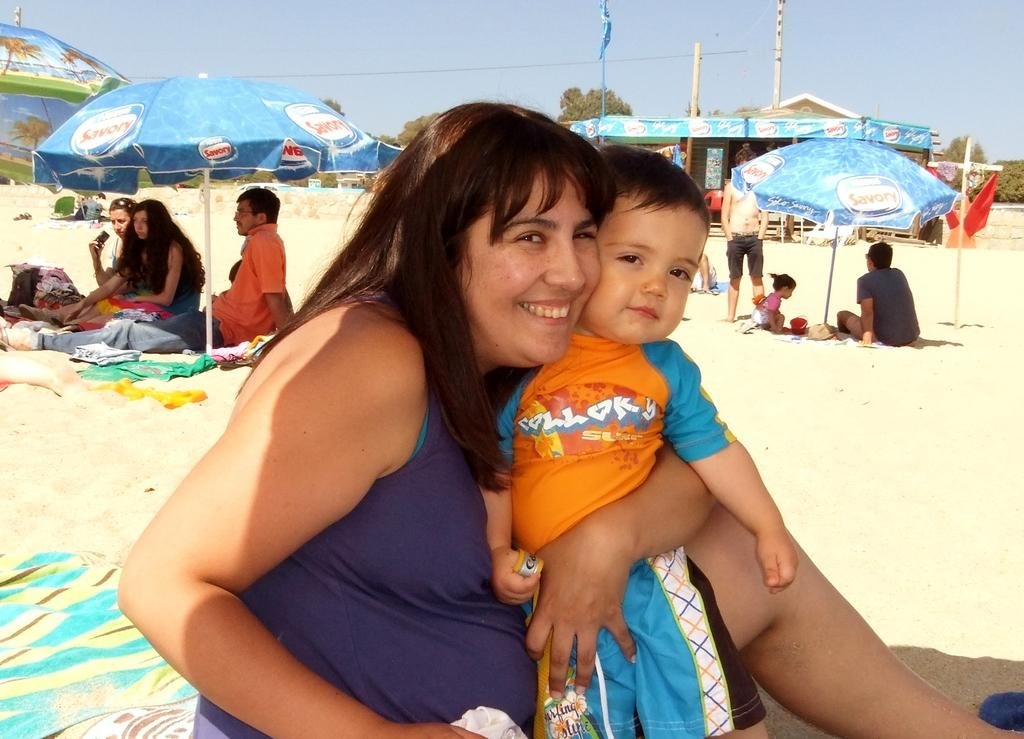What are the people in the image doing? The people in the image are sitting. How can you describe the clothing of the people in the image? The people are wearing different color dresses. What can be seen in the image besides the people? There are colorful umbrellas, a store, flagpoles, trees, sand, and a blue sky in the image. What type of leather is visible on the button in the image? There is no button or leather present in the image. What direction is the zephyr blowing in the image? There is no mention of a zephyr in the image, as it is a term used to describe a gentle breeze, which is not depicted. 